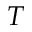Convert formula to latex. <formula><loc_0><loc_0><loc_500><loc_500>T</formula> 